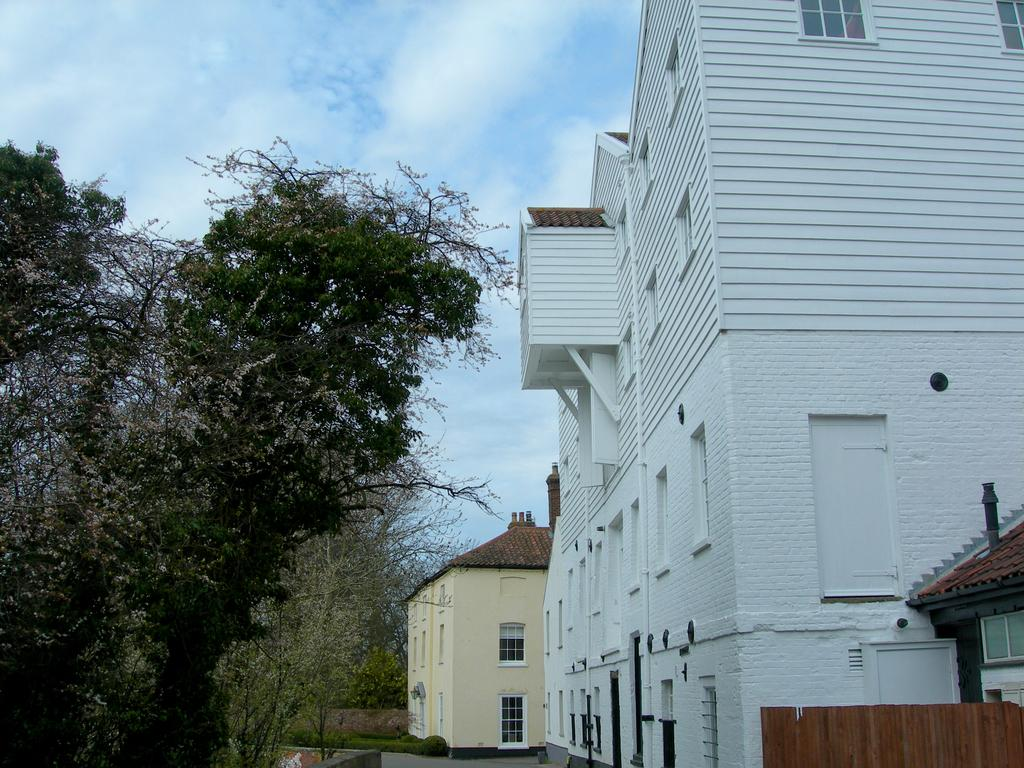What type of vegetation is on the left side of the image? There are trees on the left side of the image. What structures can be seen in the image? There are buildings in the image, located towards the right and in the center. What other type of vegetation is present in the image? There are plants in the image. What is visible at the top of the image? The sky is visible at the top of the image. Can you see the star that the buildings are using to beam their breath into the sky? There is no mention of stars, beams, or breath in the image. The image features trees, buildings, plants, and a visible sky. 